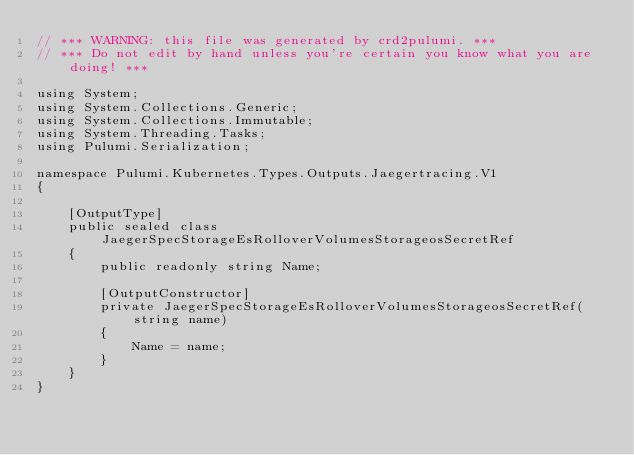<code> <loc_0><loc_0><loc_500><loc_500><_C#_>// *** WARNING: this file was generated by crd2pulumi. ***
// *** Do not edit by hand unless you're certain you know what you are doing! ***

using System;
using System.Collections.Generic;
using System.Collections.Immutable;
using System.Threading.Tasks;
using Pulumi.Serialization;

namespace Pulumi.Kubernetes.Types.Outputs.Jaegertracing.V1
{

    [OutputType]
    public sealed class JaegerSpecStorageEsRolloverVolumesStorageosSecretRef
    {
        public readonly string Name;

        [OutputConstructor]
        private JaegerSpecStorageEsRolloverVolumesStorageosSecretRef(string name)
        {
            Name = name;
        }
    }
}
</code> 